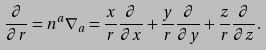Convert formula to latex. <formula><loc_0><loc_0><loc_500><loc_500>\frac { \partial } { \partial r } = n ^ { a } \nabla _ { a } = \frac { x } { r } \frac { \partial } { \partial x } + \frac { y } { r } \frac { \partial } { \partial y } + \frac { z } { r } \frac { \partial } { \partial z } .</formula> 